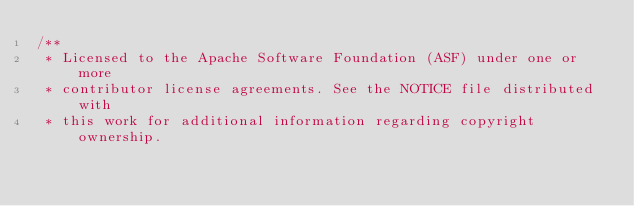Convert code to text. <code><loc_0><loc_0><loc_500><loc_500><_Java_>/**
 * Licensed to the Apache Software Foundation (ASF) under one or more
 * contributor license agreements. See the NOTICE file distributed with
 * this work for additional information regarding copyright ownership.</code> 